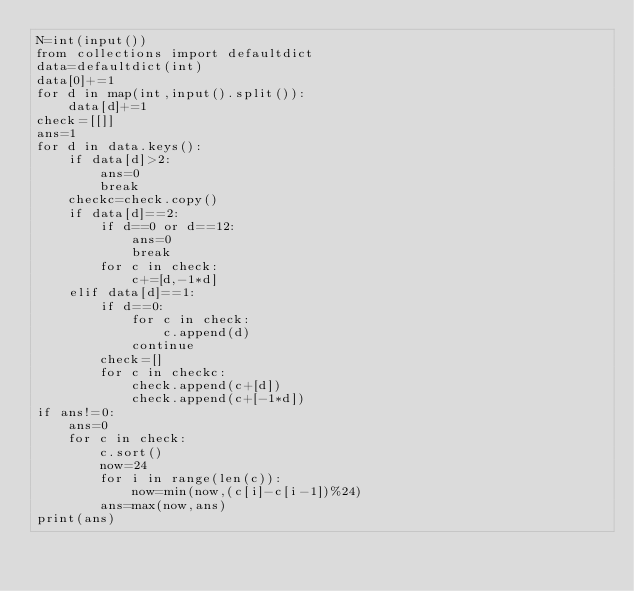Convert code to text. <code><loc_0><loc_0><loc_500><loc_500><_Python_>N=int(input())
from collections import defaultdict
data=defaultdict(int)
data[0]+=1
for d in map(int,input().split()):
    data[d]+=1
check=[[]]
ans=1
for d in data.keys():
    if data[d]>2:
        ans=0
        break
    checkc=check.copy()
    if data[d]==2:
        if d==0 or d==12:
            ans=0
            break
        for c in check:
            c+=[d,-1*d]
    elif data[d]==1:
        if d==0:
            for c in check:
                c.append(d)
            continue
        check=[]
        for c in checkc:
            check.append(c+[d])
            check.append(c+[-1*d])
if ans!=0:
    ans=0
    for c in check:
        c.sort()
        now=24
        for i in range(len(c)):
            now=min(now,(c[i]-c[i-1])%24)
        ans=max(now,ans)
print(ans)</code> 